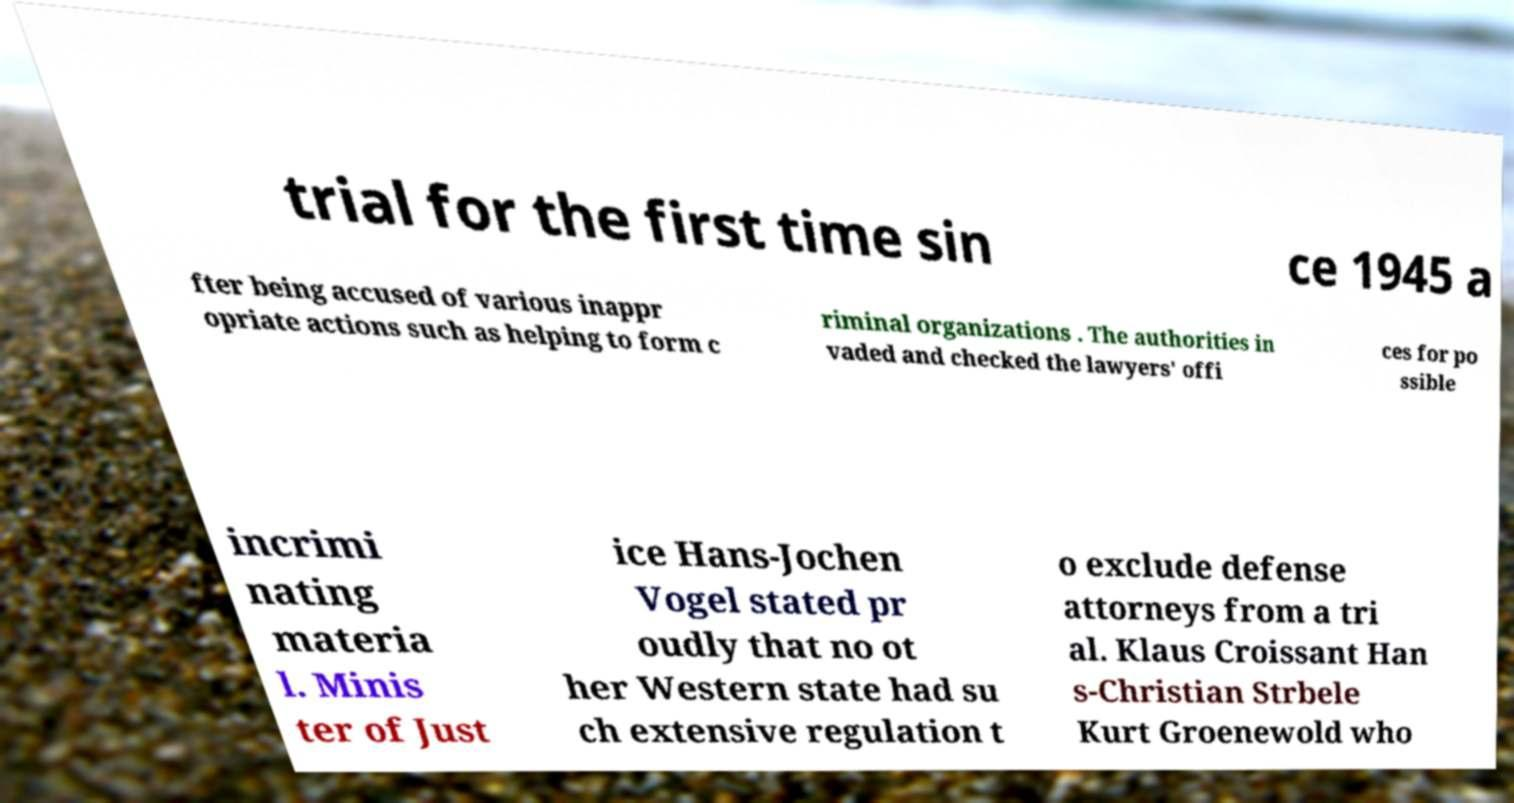What messages or text are displayed in this image? I need them in a readable, typed format. trial for the first time sin ce 1945 a fter being accused of various inappr opriate actions such as helping to form c riminal organizations . The authorities in vaded and checked the lawyers' offi ces for po ssible incrimi nating materia l. Minis ter of Just ice Hans-Jochen Vogel stated pr oudly that no ot her Western state had su ch extensive regulation t o exclude defense attorneys from a tri al. Klaus Croissant Han s-Christian Strbele Kurt Groenewold who 